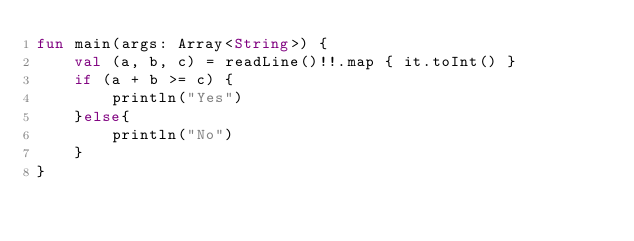<code> <loc_0><loc_0><loc_500><loc_500><_Kotlin_>fun main(args: Array<String>) {
    val (a, b, c) = readLine()!!.map { it.toInt() }
    if (a + b >= c) {
        println("Yes")
    }else{
        println("No")
    }
}</code> 